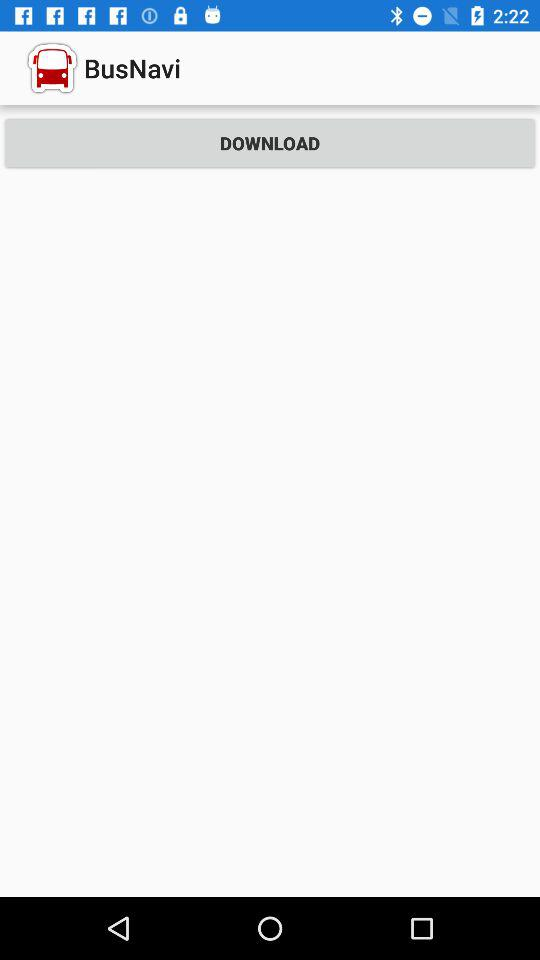How many routes can be downloaded?
When the provided information is insufficient, respond with <no answer>. <no answer> 